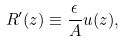<formula> <loc_0><loc_0><loc_500><loc_500>R ^ { \prime } ( z ) \equiv \frac { \epsilon } { A } u ( z ) ,</formula> 